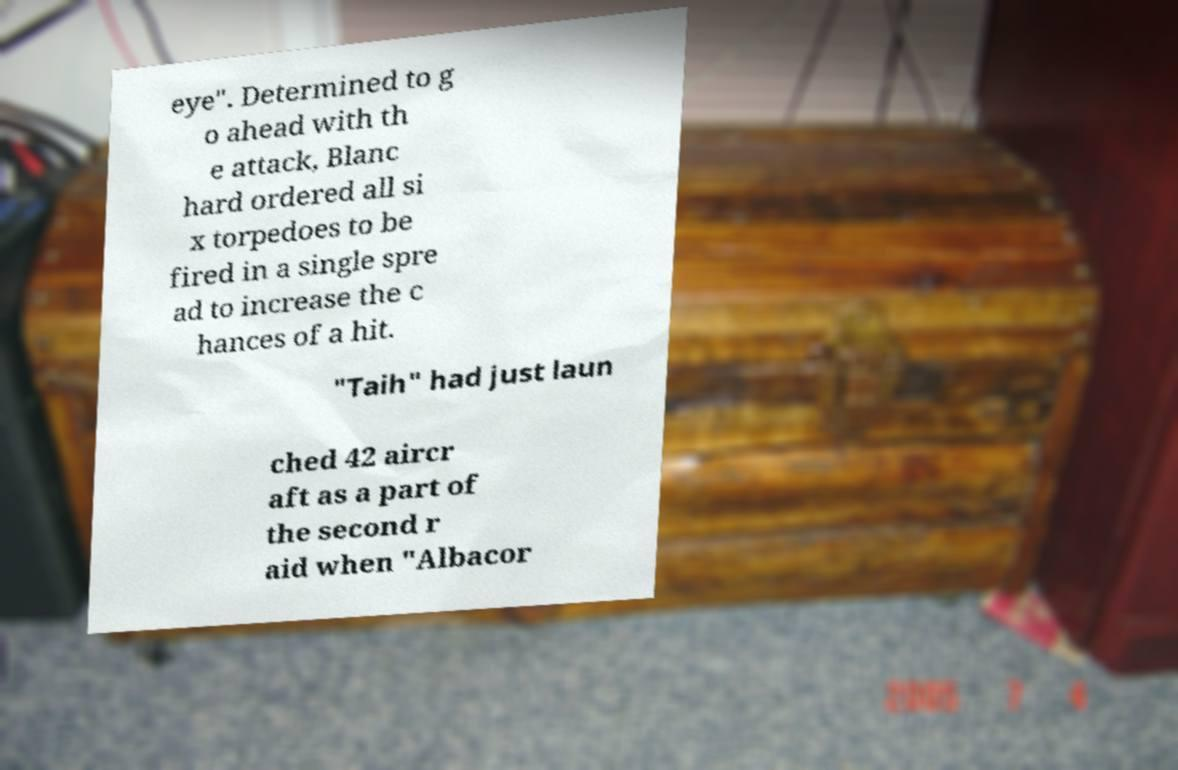Can you read and provide the text displayed in the image?This photo seems to have some interesting text. Can you extract and type it out for me? eye". Determined to g o ahead with th e attack, Blanc hard ordered all si x torpedoes to be fired in a single spre ad to increase the c hances of a hit. "Taih" had just laun ched 42 aircr aft as a part of the second r aid when "Albacor 